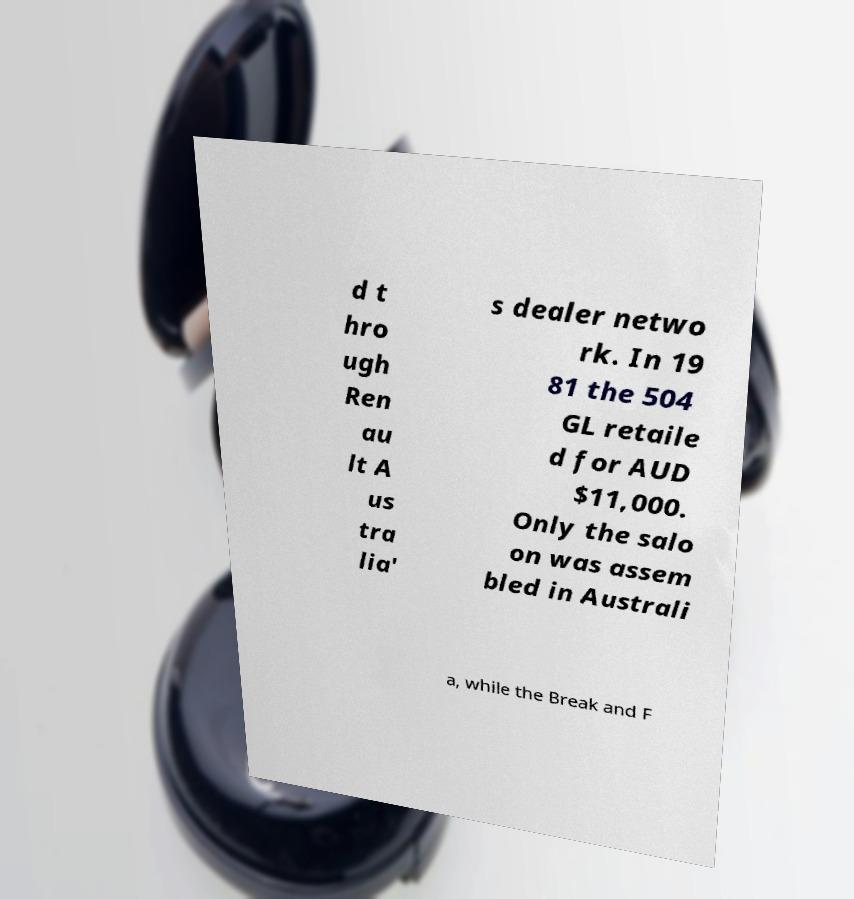Can you read and provide the text displayed in the image?This photo seems to have some interesting text. Can you extract and type it out for me? d t hro ugh Ren au lt A us tra lia' s dealer netwo rk. In 19 81 the 504 GL retaile d for AUD $11,000. Only the salo on was assem bled in Australi a, while the Break and F 